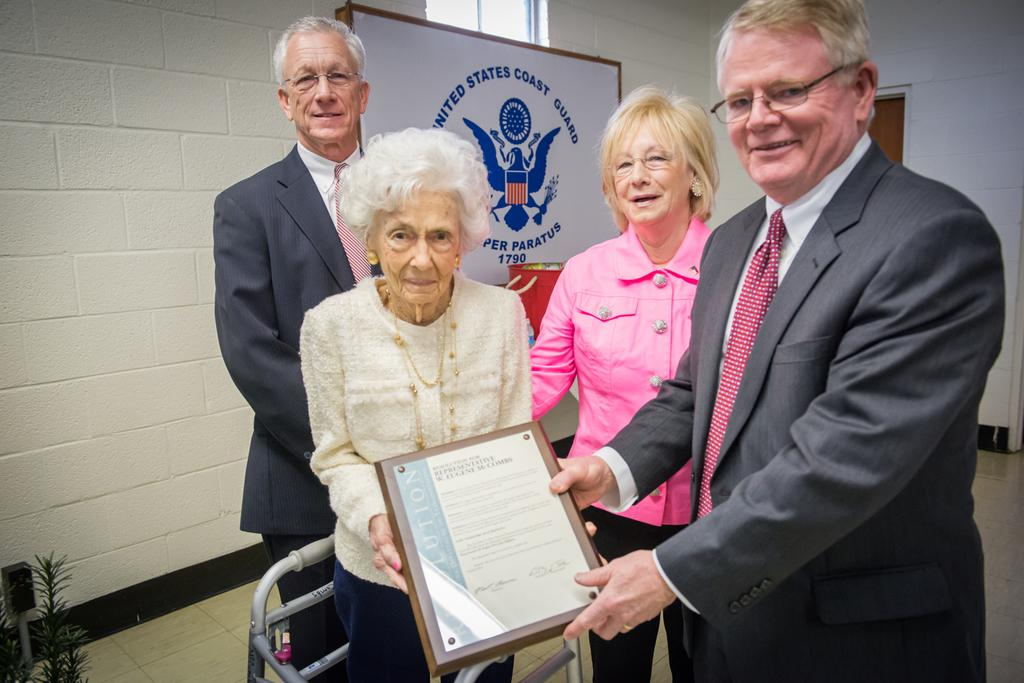How many people are present in the image? There are two women and two men in the image. What is one of the men doing in the image? A man is presenting an award. Who is receiving the award in the image? The recipient of the award is an old woman. What is the old woman wearing in the image? The old woman is wearing a white dress. What can be seen in the background of the image? There is a wall in the background of the image. What type of orange roll can be seen on the wall in the image? There is no orange roll present in the image, and the wall is not mentioned as having any food items. What flavor of mint is being used to decorate the old woman's dress in the image? There is no mention of mint or any decorations on the old woman's dress in the image. 